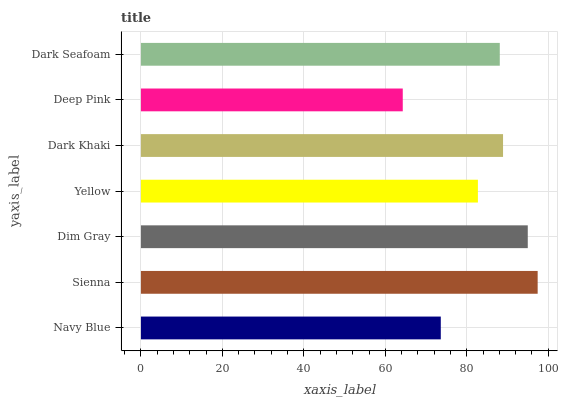Is Deep Pink the minimum?
Answer yes or no. Yes. Is Sienna the maximum?
Answer yes or no. Yes. Is Dim Gray the minimum?
Answer yes or no. No. Is Dim Gray the maximum?
Answer yes or no. No. Is Sienna greater than Dim Gray?
Answer yes or no. Yes. Is Dim Gray less than Sienna?
Answer yes or no. Yes. Is Dim Gray greater than Sienna?
Answer yes or no. No. Is Sienna less than Dim Gray?
Answer yes or no. No. Is Dark Seafoam the high median?
Answer yes or no. Yes. Is Dark Seafoam the low median?
Answer yes or no. Yes. Is Navy Blue the high median?
Answer yes or no. No. Is Sienna the low median?
Answer yes or no. No. 